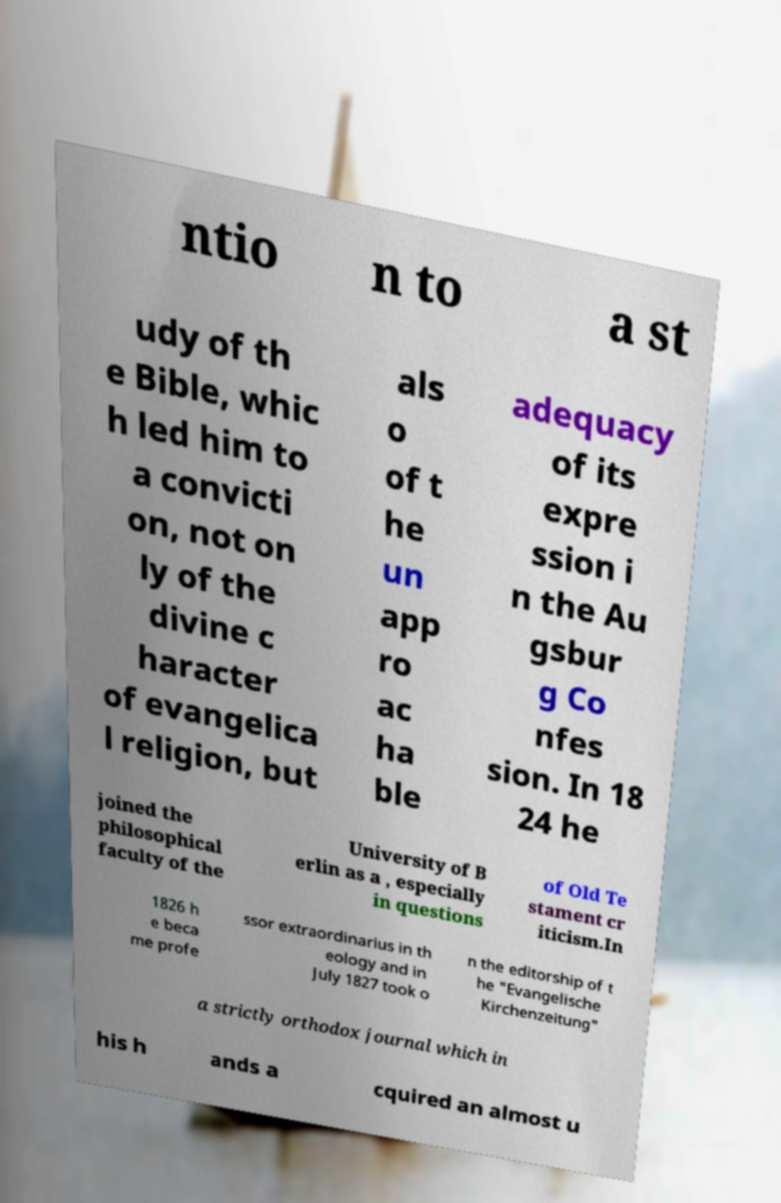I need the written content from this picture converted into text. Can you do that? ntio n to a st udy of th e Bible, whic h led him to a convicti on, not on ly of the divine c haracter of evangelica l religion, but als o of t he un app ro ac ha ble adequacy of its expre ssion i n the Au gsbur g Co nfes sion. In 18 24 he joined the philosophical faculty of the University of B erlin as a , especially in questions of Old Te stament cr iticism.In 1826 h e beca me profe ssor extraordinarius in th eology and in July 1827 took o n the editorship of t he "Evangelische Kirchenzeitung" a strictly orthodox journal which in his h ands a cquired an almost u 